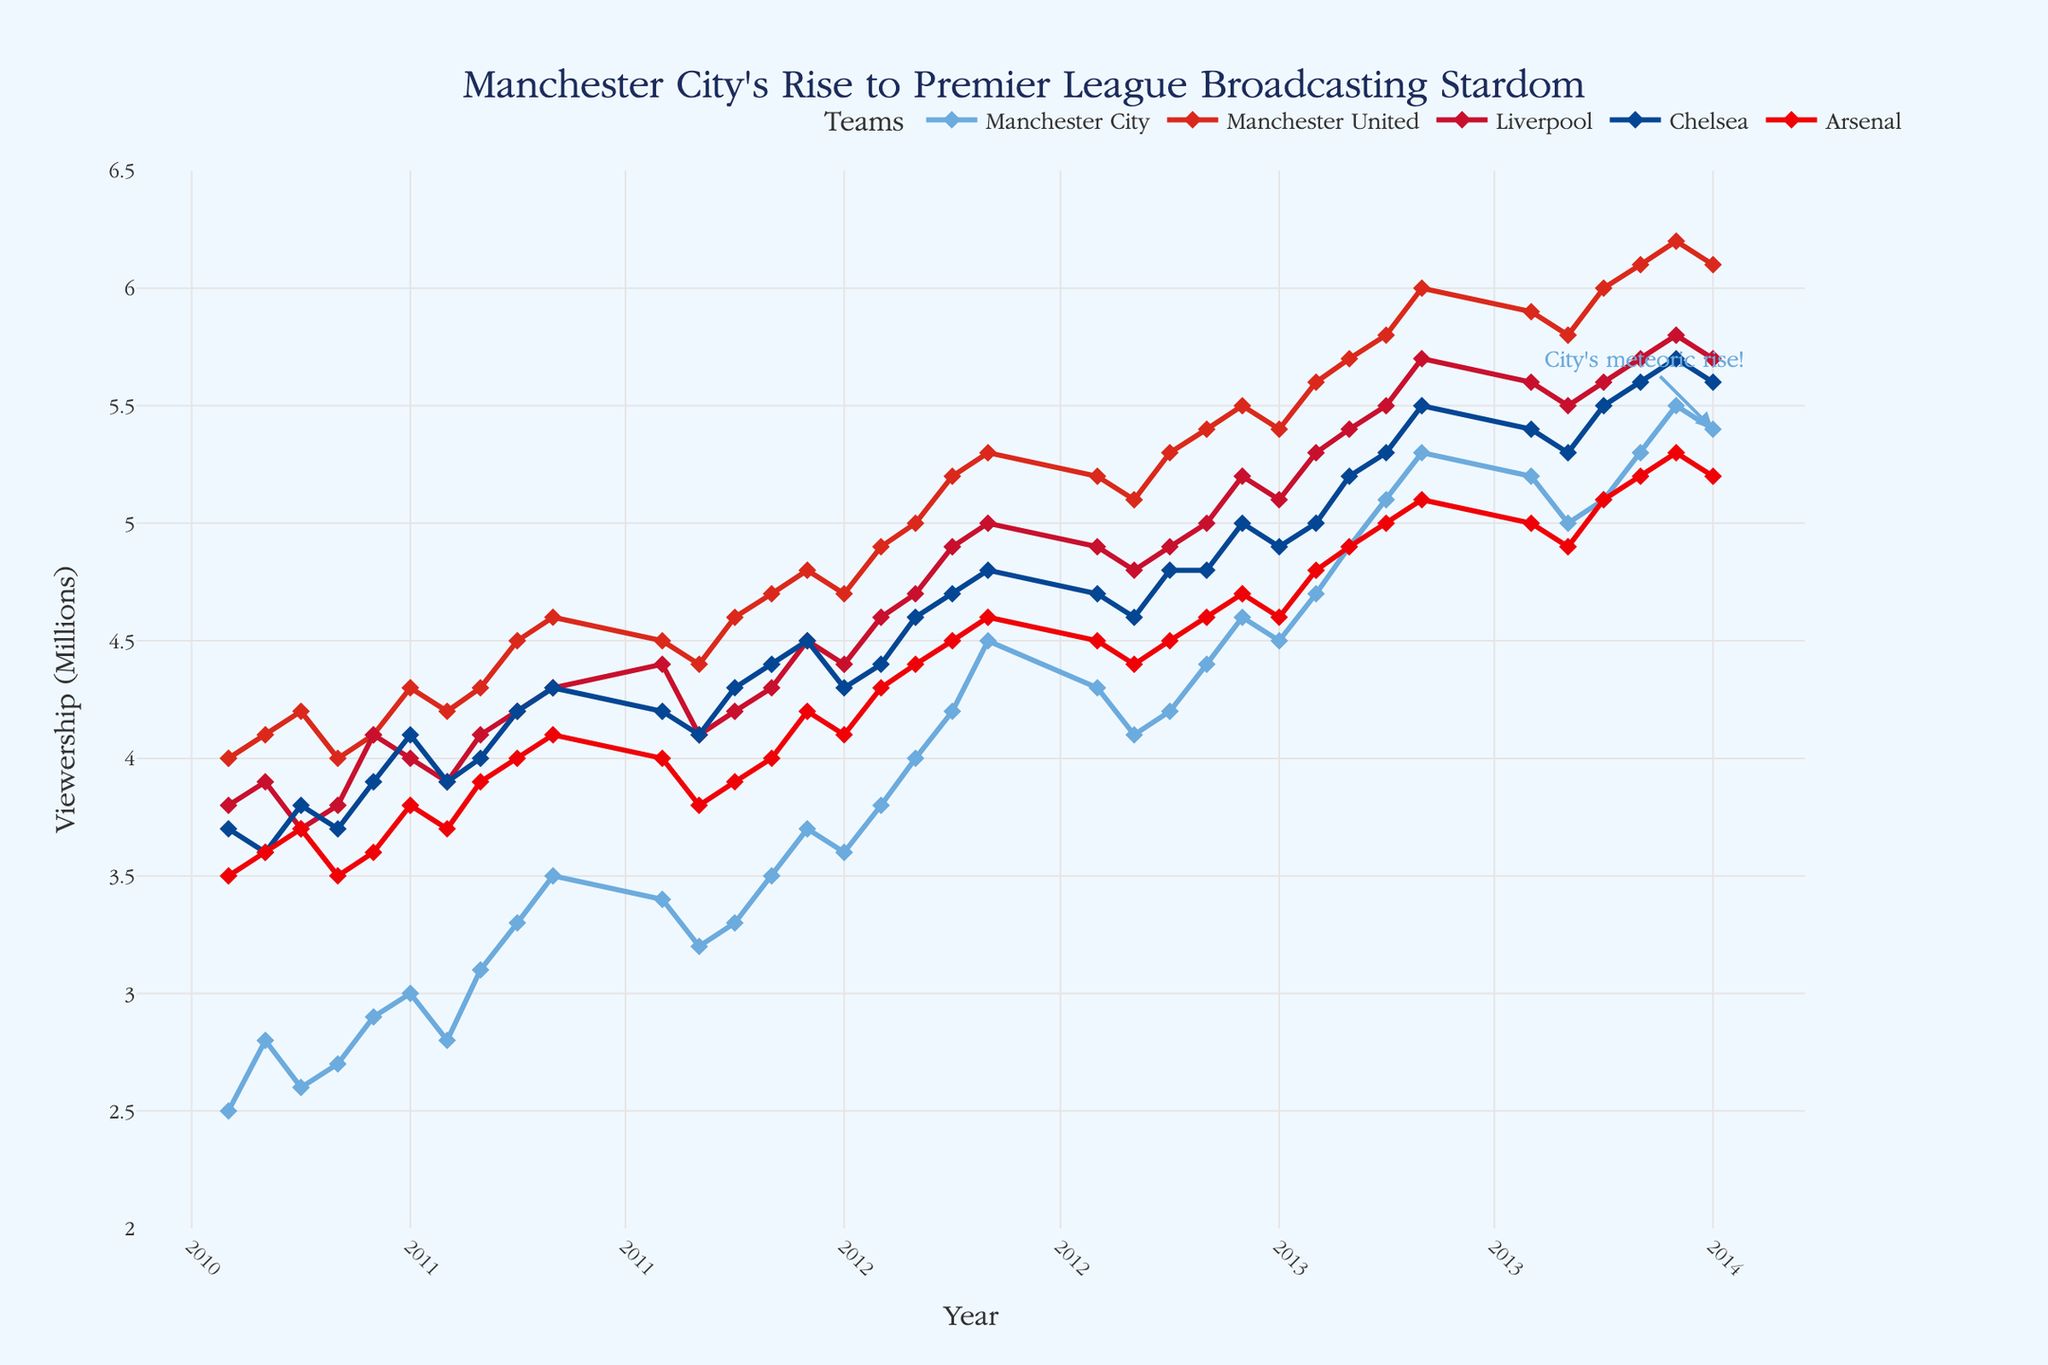What is the title of the plot? The title is usually positioned at the top center of the figure. In this case, it reads "Manchester City's Rise to Premier League Broadcasting Stardom".
Answer: Manchester City's Rise to Premier League Broadcasting Stardom What are the units used on the y-axis? The label on the y-axis indicates the units. Here, it is labeled "Viewership (Millions)", meaning the values are in millions.
Answer: Millions Which team had the highest viewership in January 2013? By checking the data points in January 2013, Manchester United had the highest viewership, with the point being at 5.4 million.
Answer: Manchester United How has Manchester City’s viewership trended from August 2010 to January 2014? Observing the points connected by the line for Manchester City from August 2010 to January 2014, we can see a clear upward trend indicating an increase in viewership over this period.
Answer: Upward trend Which teams had an increase in viewership from January 2010 to January 2014, and how did their viewership change? By comparing the viewership values in January 2010 and January 2014 for all teams, all five teams (Manchester City, Manchester United, Liverpool, Chelsea, and Arsenal) had increased viewership. For instance, Manchester City went from 2.5M to 5.4M, Manchester United from 4.0M to 6.1M, Liverpool from 3.8M to 5.7M, Chelsea from 3.7M to 5.6M, and Arsenal from 3.5M to 5.2M.
Answer: All five teams increased their viewership What was the overall trend in Premier League broadcasting viewership from August 2010 to January 2014? By observing the lines and markers for all teams, there is a general upward trend in viewership for all teams, indicating an overall increase in Premier League broadcasting viewership from August 2010 to January 2014.
Answer: Upward trend Which team showed the most significant increase in viewership from August 2010 to January 2014? By calculating the difference between August 2010 and January 2014 viewership for each team, Manchester City showed the most significant increase, rising from 2.5M to 5.4M viewership, giving an increase of 2.9M.
Answer: Manchester City What pattern emerges when comparing the viewership of Liverpool and Chelsea from August 2010 to January 2014? By visually comparing the two lines and data points for Liverpool and Chelsea, it is observed that both teams show an upward trend. However, Liverpool generally has slightly higher viewership than Chelsea throughout this period.
Answer: Liverpool higher than Chelsea When did Manchester City’s viewership surpass Liverpool's viewership for the first time? Upon examining the points, Manchester City's viewership first surpasses Liverpool's in April 2012, where City's viewership is at 4.2 million and Liverpool's is at 4.1 million.
Answer: April 2012 